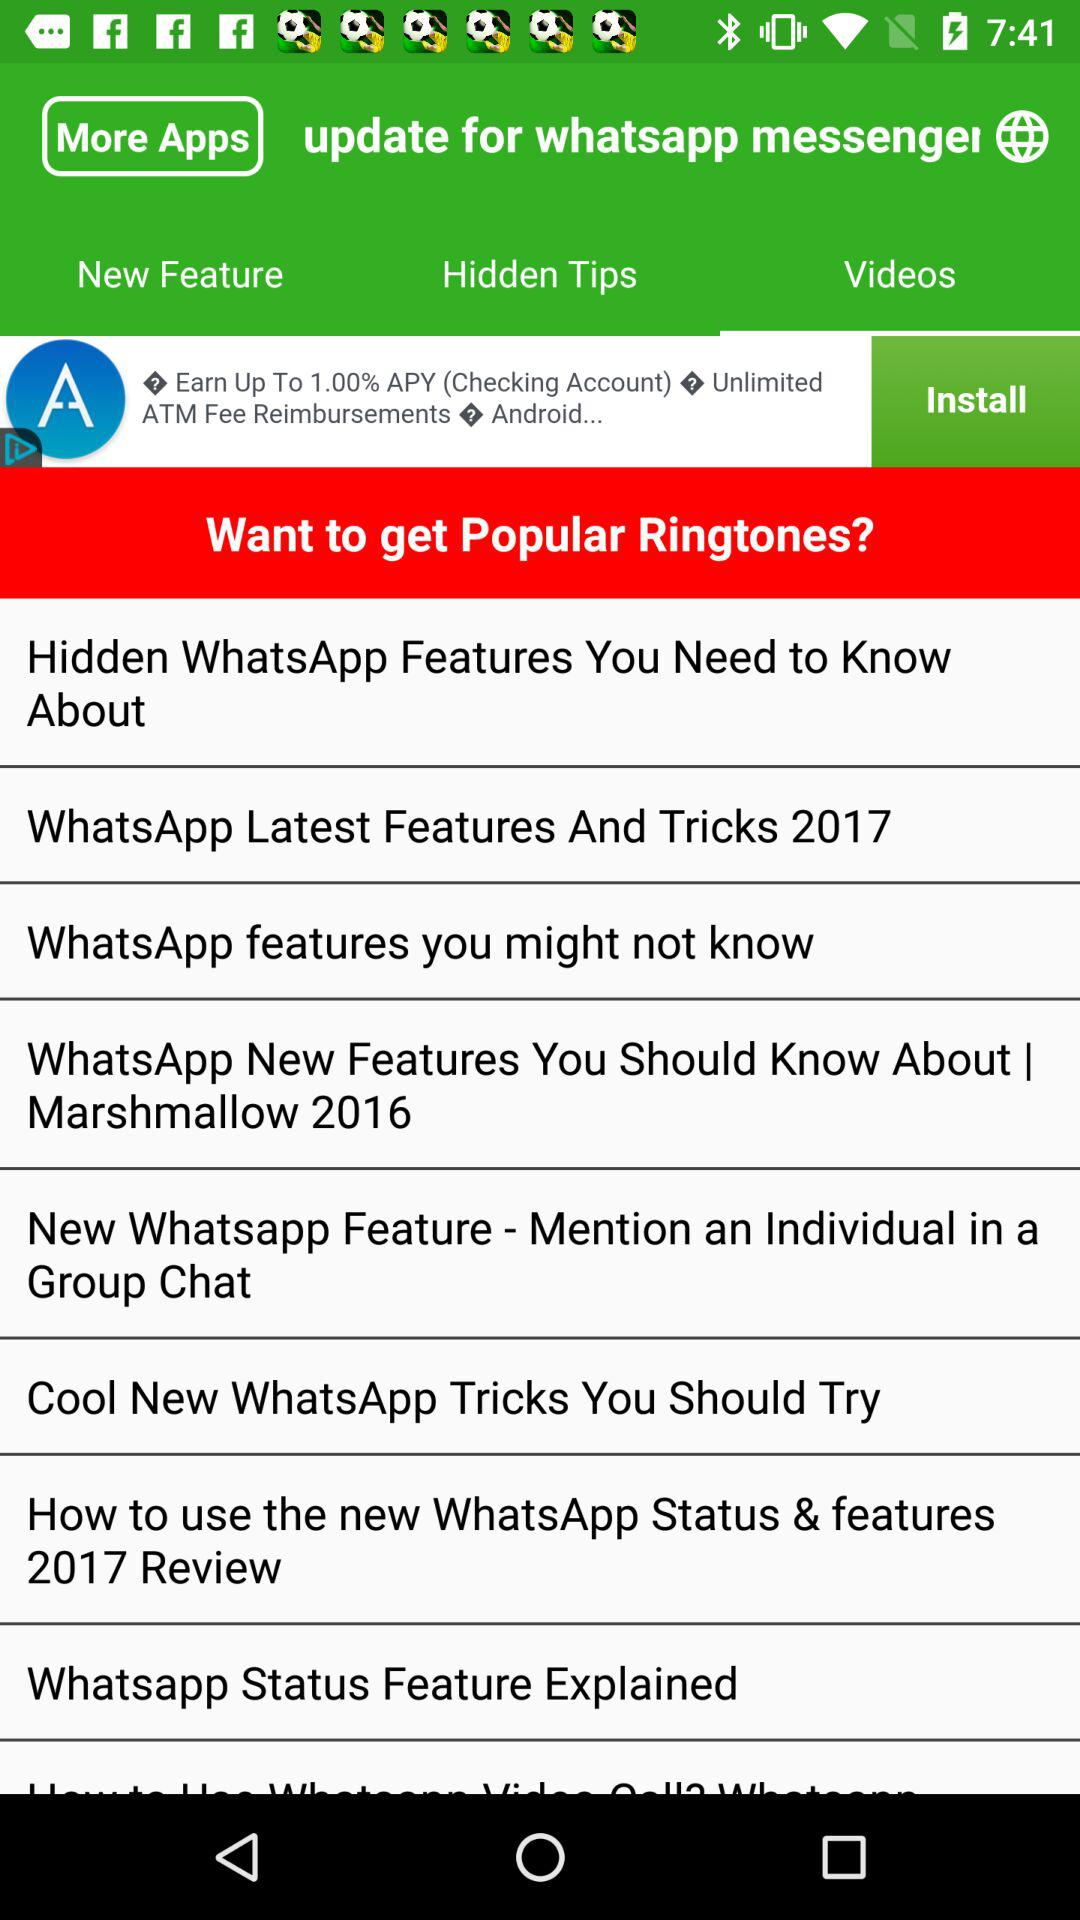Which tab is selected? The selected tab is "Videos". 